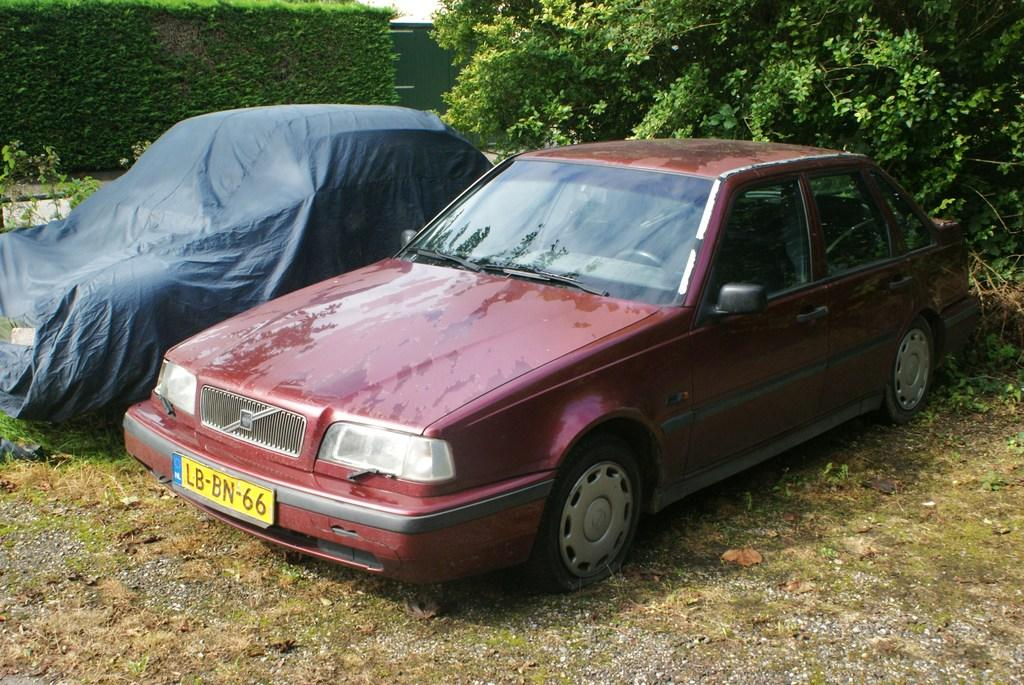What can be seen on the road in the image? There are two cars on the road in the image. What is visible in the background of the image? There are trees and a gate in the background of the image. Can you see any cobwebs hanging from the trees in the image? There is no mention of cobwebs in the image, so we cannot determine if any are present. 